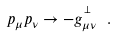<formula> <loc_0><loc_0><loc_500><loc_500>p _ { \mu } p _ { \nu } \rightarrow - g _ { \mu \nu } ^ { ^ { \perp } } \ .</formula> 